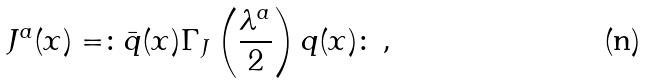<formula> <loc_0><loc_0><loc_500><loc_500>J ^ { a } ( x ) = \colon \bar { q } ( x ) \Gamma _ { J } \left ( \frac { \lambda ^ { a } } { 2 } \right ) q ( x ) \colon \, ,</formula> 